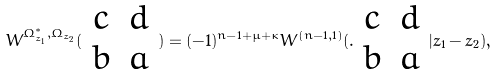<formula> <loc_0><loc_0><loc_500><loc_500>W ^ { \Omega _ { z _ { 1 } } ^ { * } , \Omega _ { z _ { 2 } } } ( \begin{array} { c c } c & d \\ b & a \end{array} ) = ( - 1 ) ^ { n - 1 + \mu + \kappa } W ^ { ( n - 1 , 1 ) } ( . \begin{array} { c c } c & d \\ b & a \end{array} | z _ { 1 } - z _ { 2 } ) ,</formula> 